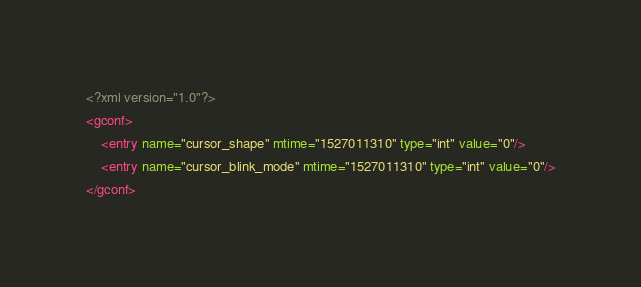<code> <loc_0><loc_0><loc_500><loc_500><_XML_><?xml version="1.0"?>
<gconf>
	<entry name="cursor_shape" mtime="1527011310" type="int" value="0"/>
	<entry name="cursor_blink_mode" mtime="1527011310" type="int" value="0"/>
</gconf>
</code> 